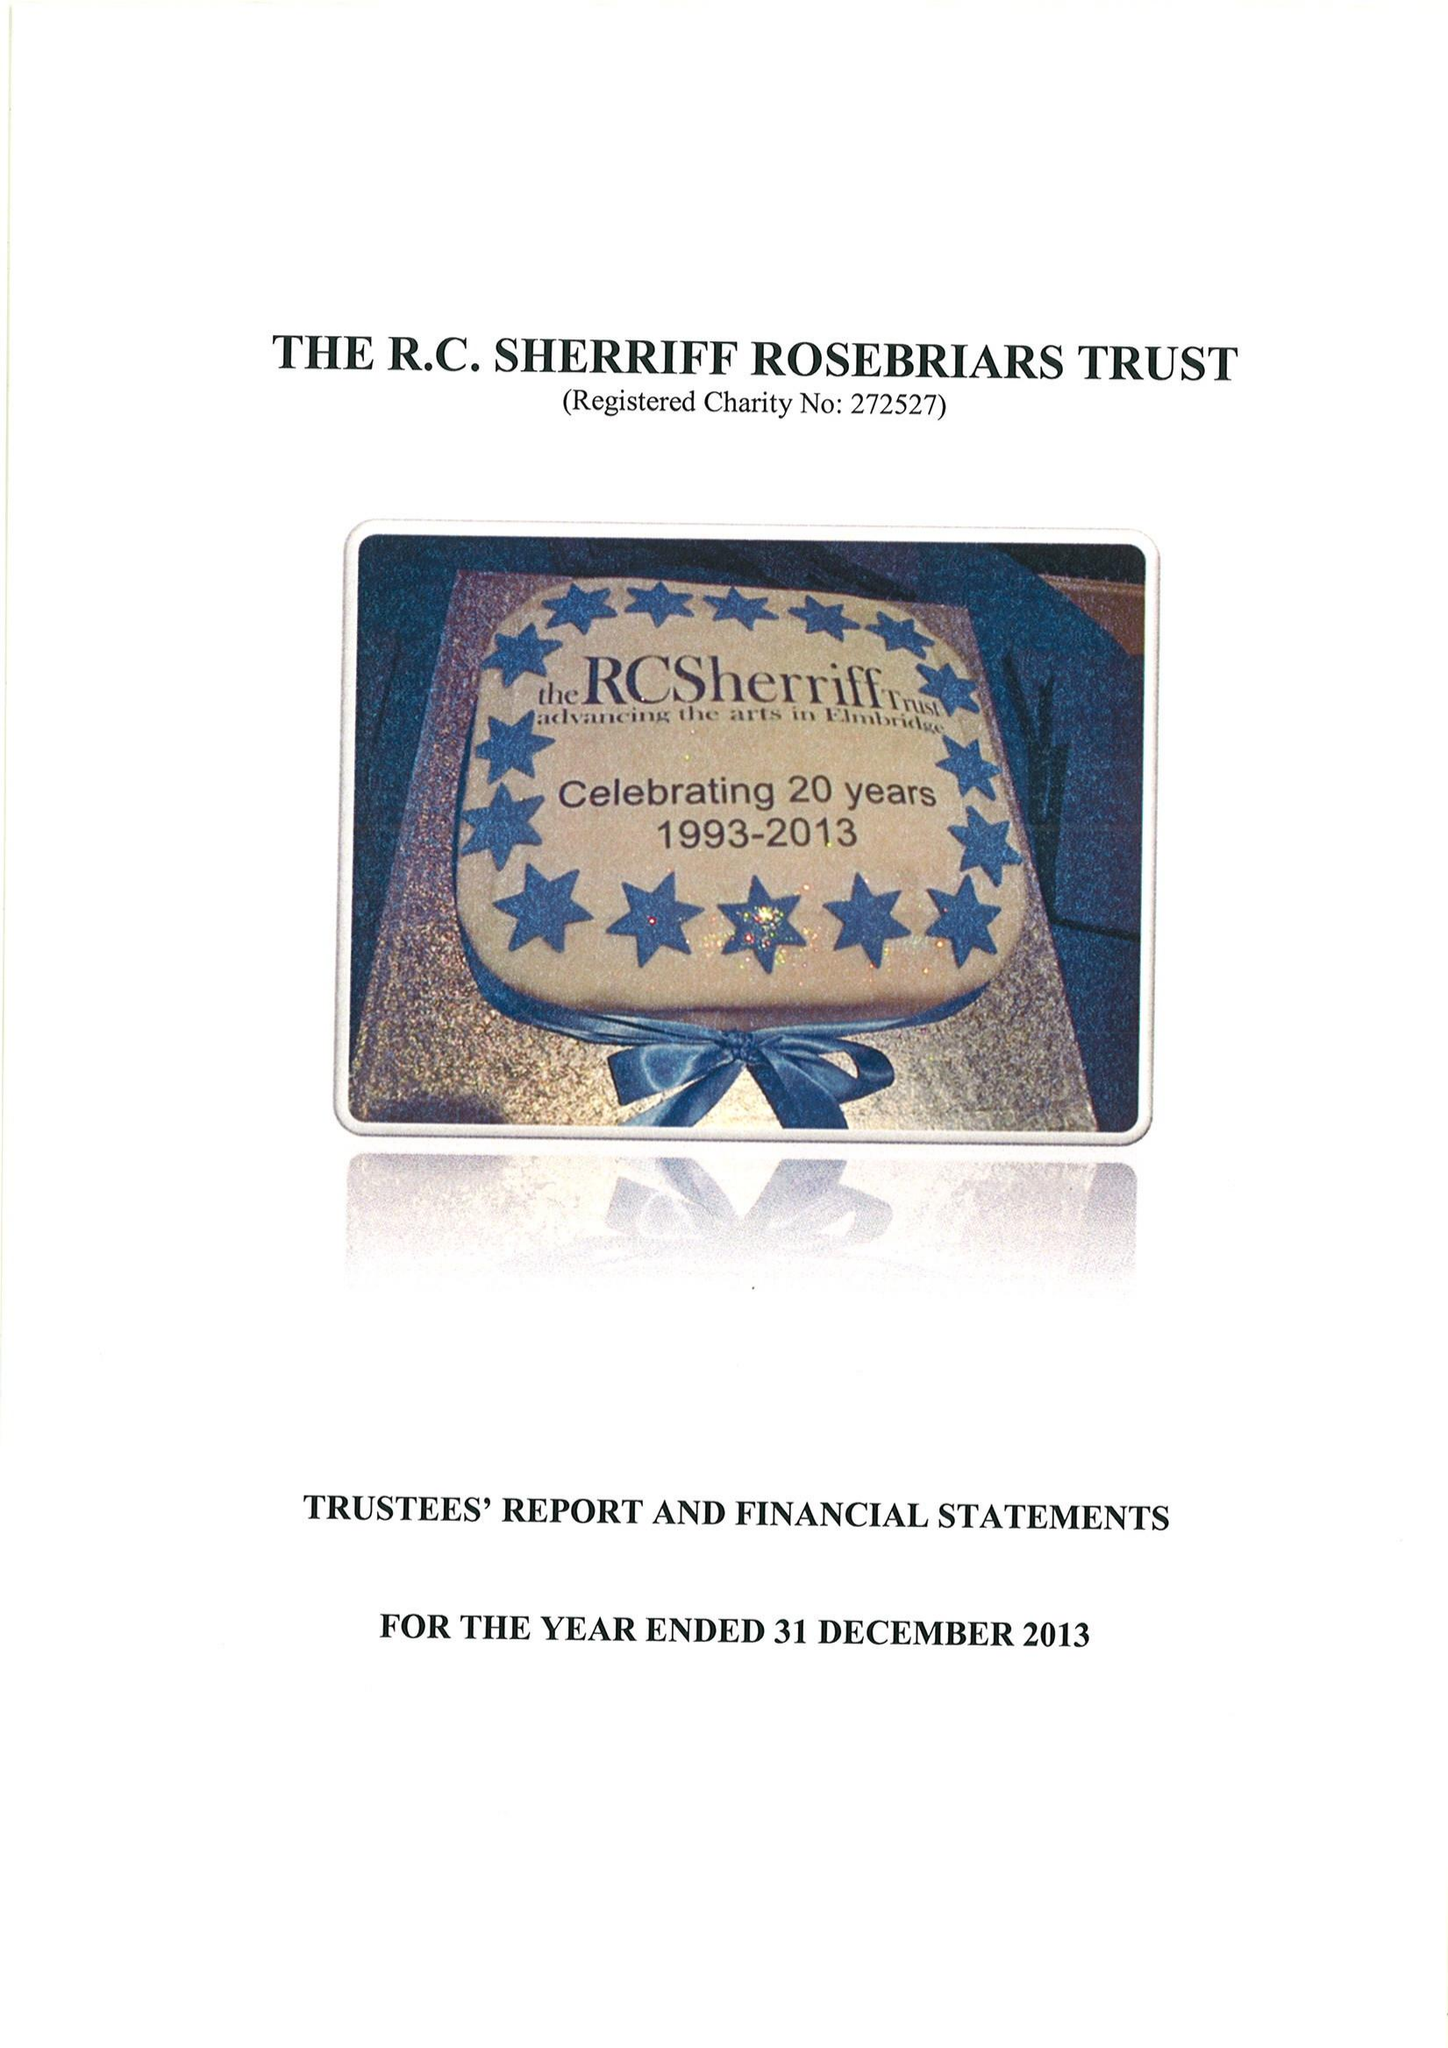What is the value for the spending_annually_in_british_pounds?
Answer the question using a single word or phrase. 230254.00 